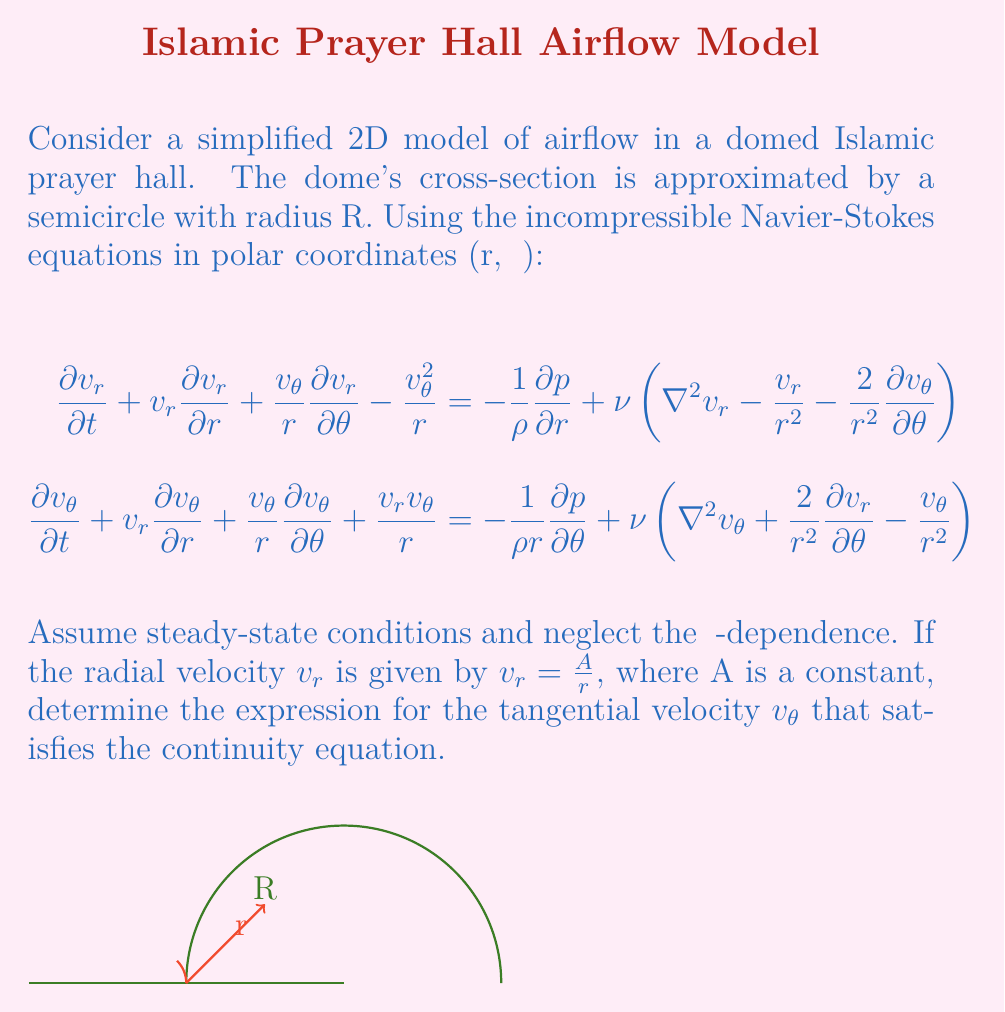Can you answer this question? Let's approach this step-by-step:

1) First, recall the continuity equation for incompressible flow in polar coordinates:

   $$\frac{1}{r}\frac{\partial}{\partial r}(rv_r) + \frac{1}{r}\frac{\partial v_\theta}{\partial \theta} = 0$$

2) Given that we're neglecting θ-dependence, the second term vanishes:

   $$\frac{1}{r}\frac{\partial}{\partial r}(rv_r) = 0$$

3) We're given that $v_r = \frac{A}{r}$. Let's substitute this into the continuity equation:

   $$\frac{1}{r}\frac{\partial}{\partial r}(r\cdot\frac{A}{r}) = 0$$

4) Simplify:

   $$\frac{1}{r}\frac{\partial}{\partial r}(A) = 0$$

5) This equation is satisfied because A is a constant, confirming that our given $v_r$ satisfies the continuity equation.

6) Now, to find $v_\theta$, we need to use the θ-component of the Navier-Stokes equation. Under steady-state conditions and neglecting θ-dependence, it simplifies to:

   $$v_r\frac{\partial v_\theta}{\partial r} + \frac{v_rv_\theta}{r} = \nu\left(\frac{\partial^2v_\theta}{\partial r^2} + \frac{1}{r}\frac{\partial v_\theta}{\partial r} - \frac{v_\theta}{r^2}\right)$$

7) Substitute $v_r = \frac{A}{r}$:

   $$\frac{A}{r}\frac{\partial v_\theta}{\partial r} + \frac{A}{r^2}v_\theta = \nu\left(\frac{\partial^2v_\theta}{\partial r^2} + \frac{1}{r}\frac{\partial v_\theta}{\partial r} - \frac{v_\theta}{r^2}\right)$$

8) This is a complex differential equation. However, we can guess a solution of the form $v_\theta = \frac{B}{r}$, where B is another constant. Let's verify:

9) If $v_\theta = \frac{B}{r}$, then:
   $\frac{\partial v_\theta}{\partial r} = -\frac{B}{r^2}$
   $\frac{\partial^2v_\theta}{\partial r^2} = \frac{2B}{r^3}$

10) Substituting these into the equation from step 7:

    $$\frac{A}{r}\left(-\frac{B}{r^2}\right) + \frac{A}{r^2}\frac{B}{r} = \nu\left(\frac{2B}{r^3} - \frac{B}{r^3} - \frac{B}{r^3}\right)$$

11) Simplify:

    $$-\frac{AB}{r^3} + \frac{AB}{r^3} = 0$$

12) This equation is satisfied, confirming that $v_\theta = \frac{B}{r}$ is indeed a solution.
Answer: $v_\theta = \frac{B}{r}$, where B is a constant. 